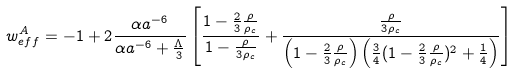Convert formula to latex. <formula><loc_0><loc_0><loc_500><loc_500>w ^ { A } _ { e f f } = - 1 + 2 \frac { \alpha a ^ { - 6 } } { \alpha a ^ { - 6 } + \frac { \Lambda } { 3 } } \left [ \frac { 1 - \frac { 2 } { 3 } \frac { \rho } { \rho _ { c } } } { 1 - \frac { \rho } { 3 \rho _ { c } } } + \frac { \frac { \rho } { 3 \rho _ { c } } } { \left ( 1 - \frac { 2 } { 3 } \frac { \rho } { \rho _ { c } } \right ) \left ( \frac { 3 } { 4 } ( 1 - \frac { 2 } { 3 } \frac { \rho } { \rho _ { c } } ) ^ { 2 } + \frac { 1 } { 4 } \right ) } \right ]</formula> 